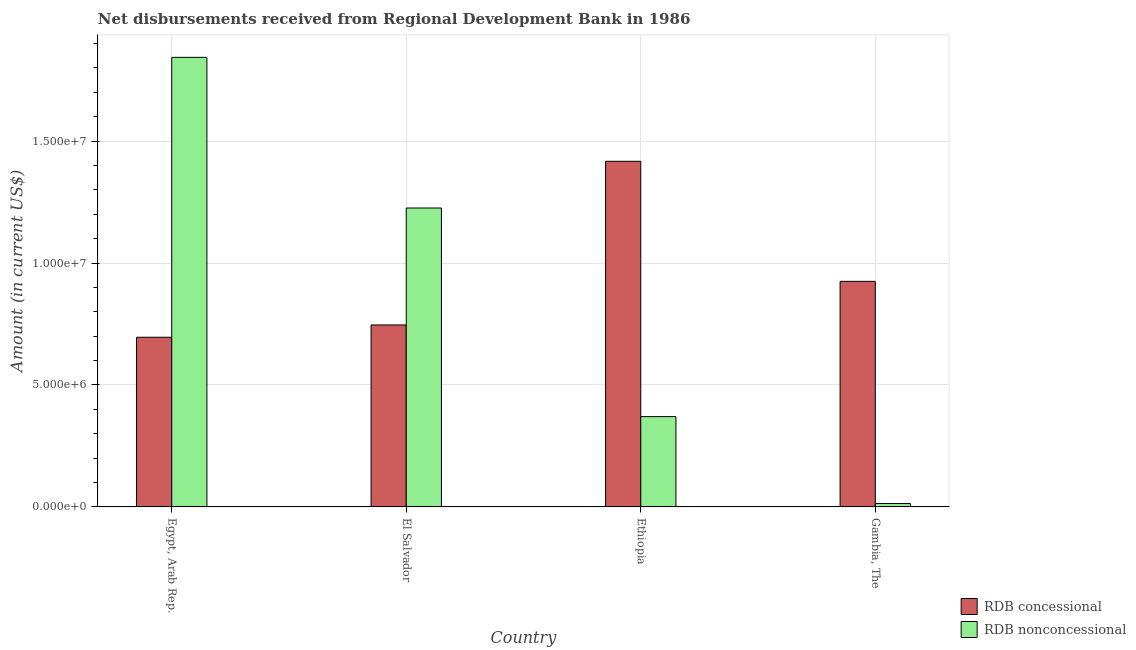Are the number of bars per tick equal to the number of legend labels?
Give a very brief answer. Yes. What is the label of the 4th group of bars from the left?
Provide a short and direct response. Gambia, The. What is the net non concessional disbursements from rdb in El Salvador?
Offer a terse response. 1.23e+07. Across all countries, what is the maximum net concessional disbursements from rdb?
Make the answer very short. 1.42e+07. Across all countries, what is the minimum net non concessional disbursements from rdb?
Give a very brief answer. 1.39e+05. In which country was the net concessional disbursements from rdb maximum?
Give a very brief answer. Ethiopia. In which country was the net concessional disbursements from rdb minimum?
Give a very brief answer. Egypt, Arab Rep. What is the total net concessional disbursements from rdb in the graph?
Give a very brief answer. 3.78e+07. What is the difference between the net non concessional disbursements from rdb in El Salvador and that in Gambia, The?
Ensure brevity in your answer.  1.21e+07. What is the difference between the net non concessional disbursements from rdb in Gambia, The and the net concessional disbursements from rdb in Ethiopia?
Give a very brief answer. -1.40e+07. What is the average net non concessional disbursements from rdb per country?
Provide a succinct answer. 8.63e+06. What is the difference between the net non concessional disbursements from rdb and net concessional disbursements from rdb in Egypt, Arab Rep.?
Provide a short and direct response. 1.15e+07. In how many countries, is the net concessional disbursements from rdb greater than 6000000 US$?
Your response must be concise. 4. What is the ratio of the net concessional disbursements from rdb in Egypt, Arab Rep. to that in El Salvador?
Provide a succinct answer. 0.93. Is the net non concessional disbursements from rdb in El Salvador less than that in Gambia, The?
Offer a terse response. No. What is the difference between the highest and the second highest net non concessional disbursements from rdb?
Keep it short and to the point. 6.18e+06. What is the difference between the highest and the lowest net non concessional disbursements from rdb?
Your answer should be compact. 1.83e+07. In how many countries, is the net non concessional disbursements from rdb greater than the average net non concessional disbursements from rdb taken over all countries?
Provide a succinct answer. 2. What does the 1st bar from the left in Egypt, Arab Rep. represents?
Keep it short and to the point. RDB concessional. What does the 1st bar from the right in El Salvador represents?
Offer a very short reply. RDB nonconcessional. How many bars are there?
Give a very brief answer. 8. Are all the bars in the graph horizontal?
Ensure brevity in your answer.  No. Does the graph contain any zero values?
Provide a succinct answer. No. How many legend labels are there?
Your answer should be compact. 2. How are the legend labels stacked?
Keep it short and to the point. Vertical. What is the title of the graph?
Ensure brevity in your answer.  Net disbursements received from Regional Development Bank in 1986. Does "Primary education" appear as one of the legend labels in the graph?
Give a very brief answer. No. What is the label or title of the X-axis?
Make the answer very short. Country. What is the Amount (in current US$) of RDB concessional in Egypt, Arab Rep.?
Your answer should be very brief. 6.96e+06. What is the Amount (in current US$) in RDB nonconcessional in Egypt, Arab Rep.?
Make the answer very short. 1.84e+07. What is the Amount (in current US$) of RDB concessional in El Salvador?
Make the answer very short. 7.46e+06. What is the Amount (in current US$) of RDB nonconcessional in El Salvador?
Your answer should be compact. 1.23e+07. What is the Amount (in current US$) of RDB concessional in Ethiopia?
Ensure brevity in your answer.  1.42e+07. What is the Amount (in current US$) in RDB nonconcessional in Ethiopia?
Give a very brief answer. 3.70e+06. What is the Amount (in current US$) in RDB concessional in Gambia, The?
Ensure brevity in your answer.  9.25e+06. What is the Amount (in current US$) of RDB nonconcessional in Gambia, The?
Offer a terse response. 1.39e+05. Across all countries, what is the maximum Amount (in current US$) of RDB concessional?
Ensure brevity in your answer.  1.42e+07. Across all countries, what is the maximum Amount (in current US$) of RDB nonconcessional?
Your response must be concise. 1.84e+07. Across all countries, what is the minimum Amount (in current US$) in RDB concessional?
Give a very brief answer. 6.96e+06. Across all countries, what is the minimum Amount (in current US$) of RDB nonconcessional?
Make the answer very short. 1.39e+05. What is the total Amount (in current US$) in RDB concessional in the graph?
Provide a short and direct response. 3.78e+07. What is the total Amount (in current US$) of RDB nonconcessional in the graph?
Your response must be concise. 3.45e+07. What is the difference between the Amount (in current US$) in RDB concessional in Egypt, Arab Rep. and that in El Salvador?
Make the answer very short. -5.05e+05. What is the difference between the Amount (in current US$) in RDB nonconcessional in Egypt, Arab Rep. and that in El Salvador?
Give a very brief answer. 6.18e+06. What is the difference between the Amount (in current US$) in RDB concessional in Egypt, Arab Rep. and that in Ethiopia?
Give a very brief answer. -7.21e+06. What is the difference between the Amount (in current US$) in RDB nonconcessional in Egypt, Arab Rep. and that in Ethiopia?
Offer a terse response. 1.47e+07. What is the difference between the Amount (in current US$) of RDB concessional in Egypt, Arab Rep. and that in Gambia, The?
Make the answer very short. -2.29e+06. What is the difference between the Amount (in current US$) of RDB nonconcessional in Egypt, Arab Rep. and that in Gambia, The?
Offer a terse response. 1.83e+07. What is the difference between the Amount (in current US$) of RDB concessional in El Salvador and that in Ethiopia?
Ensure brevity in your answer.  -6.71e+06. What is the difference between the Amount (in current US$) in RDB nonconcessional in El Salvador and that in Ethiopia?
Provide a short and direct response. 8.55e+06. What is the difference between the Amount (in current US$) in RDB concessional in El Salvador and that in Gambia, The?
Your answer should be very brief. -1.79e+06. What is the difference between the Amount (in current US$) in RDB nonconcessional in El Salvador and that in Gambia, The?
Ensure brevity in your answer.  1.21e+07. What is the difference between the Amount (in current US$) in RDB concessional in Ethiopia and that in Gambia, The?
Provide a short and direct response. 4.92e+06. What is the difference between the Amount (in current US$) of RDB nonconcessional in Ethiopia and that in Gambia, The?
Your answer should be compact. 3.56e+06. What is the difference between the Amount (in current US$) in RDB concessional in Egypt, Arab Rep. and the Amount (in current US$) in RDB nonconcessional in El Salvador?
Provide a short and direct response. -5.30e+06. What is the difference between the Amount (in current US$) of RDB concessional in Egypt, Arab Rep. and the Amount (in current US$) of RDB nonconcessional in Ethiopia?
Your response must be concise. 3.25e+06. What is the difference between the Amount (in current US$) of RDB concessional in Egypt, Arab Rep. and the Amount (in current US$) of RDB nonconcessional in Gambia, The?
Your answer should be very brief. 6.82e+06. What is the difference between the Amount (in current US$) of RDB concessional in El Salvador and the Amount (in current US$) of RDB nonconcessional in Ethiopia?
Your response must be concise. 3.76e+06. What is the difference between the Amount (in current US$) in RDB concessional in El Salvador and the Amount (in current US$) in RDB nonconcessional in Gambia, The?
Provide a short and direct response. 7.32e+06. What is the difference between the Amount (in current US$) in RDB concessional in Ethiopia and the Amount (in current US$) in RDB nonconcessional in Gambia, The?
Keep it short and to the point. 1.40e+07. What is the average Amount (in current US$) of RDB concessional per country?
Offer a very short reply. 9.46e+06. What is the average Amount (in current US$) of RDB nonconcessional per country?
Provide a succinct answer. 8.63e+06. What is the difference between the Amount (in current US$) in RDB concessional and Amount (in current US$) in RDB nonconcessional in Egypt, Arab Rep.?
Your answer should be compact. -1.15e+07. What is the difference between the Amount (in current US$) of RDB concessional and Amount (in current US$) of RDB nonconcessional in El Salvador?
Your answer should be very brief. -4.79e+06. What is the difference between the Amount (in current US$) of RDB concessional and Amount (in current US$) of RDB nonconcessional in Ethiopia?
Offer a very short reply. 1.05e+07. What is the difference between the Amount (in current US$) in RDB concessional and Amount (in current US$) in RDB nonconcessional in Gambia, The?
Offer a terse response. 9.11e+06. What is the ratio of the Amount (in current US$) in RDB concessional in Egypt, Arab Rep. to that in El Salvador?
Offer a very short reply. 0.93. What is the ratio of the Amount (in current US$) in RDB nonconcessional in Egypt, Arab Rep. to that in El Salvador?
Make the answer very short. 1.5. What is the ratio of the Amount (in current US$) in RDB concessional in Egypt, Arab Rep. to that in Ethiopia?
Provide a short and direct response. 0.49. What is the ratio of the Amount (in current US$) in RDB nonconcessional in Egypt, Arab Rep. to that in Ethiopia?
Make the answer very short. 4.98. What is the ratio of the Amount (in current US$) in RDB concessional in Egypt, Arab Rep. to that in Gambia, The?
Keep it short and to the point. 0.75. What is the ratio of the Amount (in current US$) in RDB nonconcessional in Egypt, Arab Rep. to that in Gambia, The?
Provide a succinct answer. 132.6. What is the ratio of the Amount (in current US$) in RDB concessional in El Salvador to that in Ethiopia?
Your response must be concise. 0.53. What is the ratio of the Amount (in current US$) of RDB nonconcessional in El Salvador to that in Ethiopia?
Offer a very short reply. 3.31. What is the ratio of the Amount (in current US$) in RDB concessional in El Salvador to that in Gambia, The?
Give a very brief answer. 0.81. What is the ratio of the Amount (in current US$) of RDB nonconcessional in El Salvador to that in Gambia, The?
Offer a very short reply. 88.17. What is the ratio of the Amount (in current US$) of RDB concessional in Ethiopia to that in Gambia, The?
Your response must be concise. 1.53. What is the ratio of the Amount (in current US$) of RDB nonconcessional in Ethiopia to that in Gambia, The?
Give a very brief answer. 26.64. What is the difference between the highest and the second highest Amount (in current US$) in RDB concessional?
Provide a short and direct response. 4.92e+06. What is the difference between the highest and the second highest Amount (in current US$) in RDB nonconcessional?
Ensure brevity in your answer.  6.18e+06. What is the difference between the highest and the lowest Amount (in current US$) in RDB concessional?
Provide a succinct answer. 7.21e+06. What is the difference between the highest and the lowest Amount (in current US$) of RDB nonconcessional?
Offer a very short reply. 1.83e+07. 